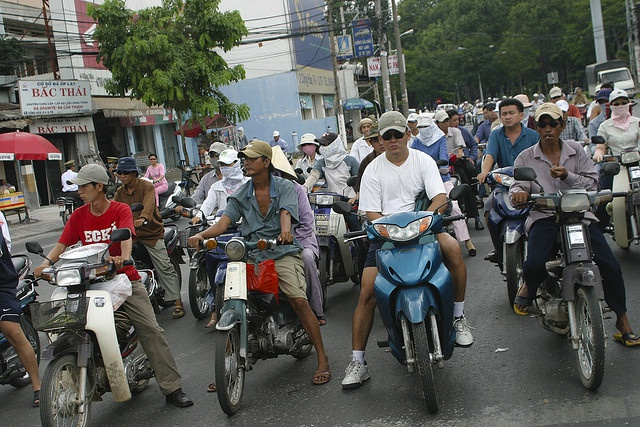Describe the objects in this image and their specific colors. I can see motorcycle in gray, black, darkgray, and lightgray tones, people in gray, black, darkgray, and lightgray tones, motorcycle in gray, black, and blue tones, people in gray, black, and darkgray tones, and people in gray, lightgray, black, and darkgray tones in this image. 